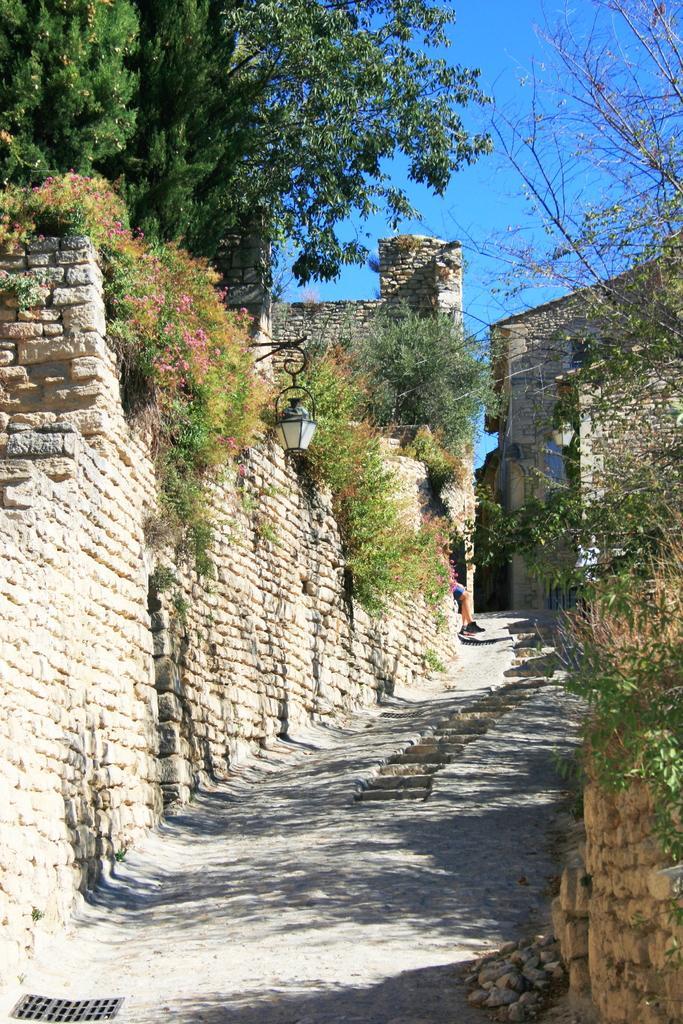Can you describe this image briefly? In this image I can see the road, few stairs and the walls which are made up of bricks on both sides of the road. I can see few trees, few flowers which are pink in color, few buildings and in the background I can see the sky. 